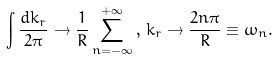<formula> <loc_0><loc_0><loc_500><loc_500>\int \frac { d k _ { r } } { 2 \pi } \rightarrow \frac { 1 } { R } \sum _ { n = - \infty } ^ { + \infty } \, , \, k _ { r } \rightarrow \frac { 2 n \pi } { R } \equiv \omega _ { n } .</formula> 